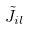<formula> <loc_0><loc_0><loc_500><loc_500>\tilde { J } _ { i l }</formula> 